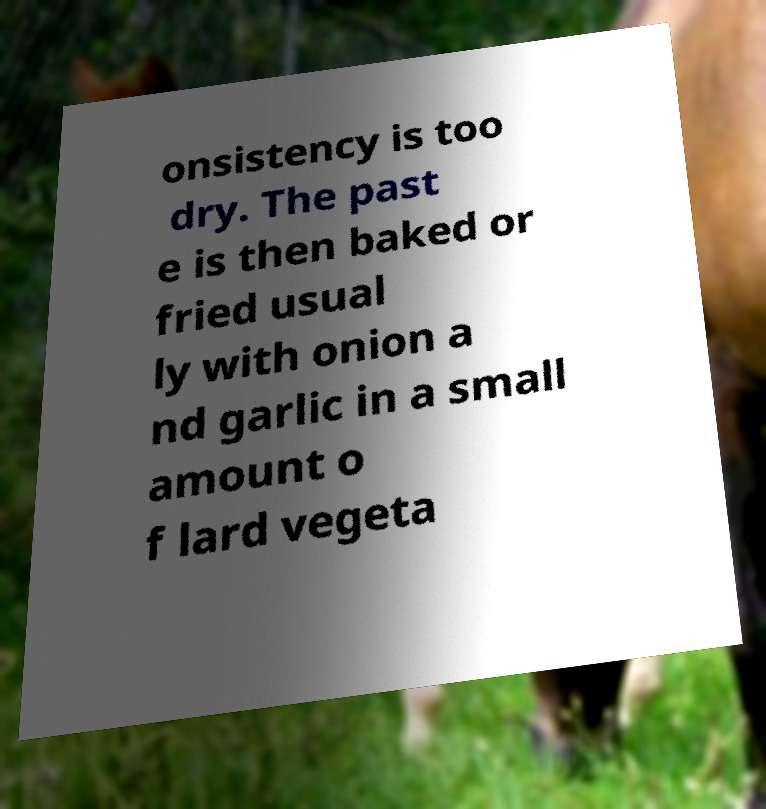Please identify and transcribe the text found in this image. onsistency is too dry. The past e is then baked or fried usual ly with onion a nd garlic in a small amount o f lard vegeta 